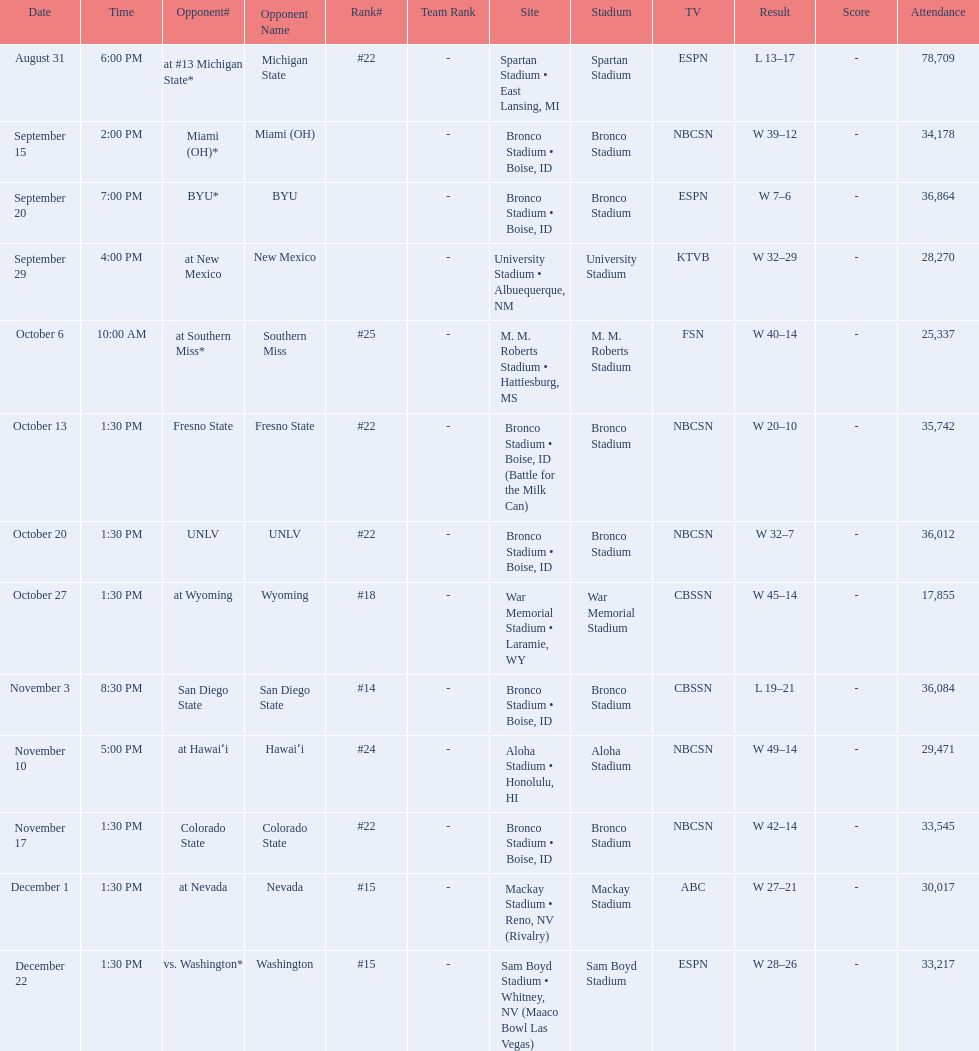What are all of the rankings? #22, , , , #25, #22, #22, #18, #14, #24, #22, #15, #15. Which of them was the best position? #14. 